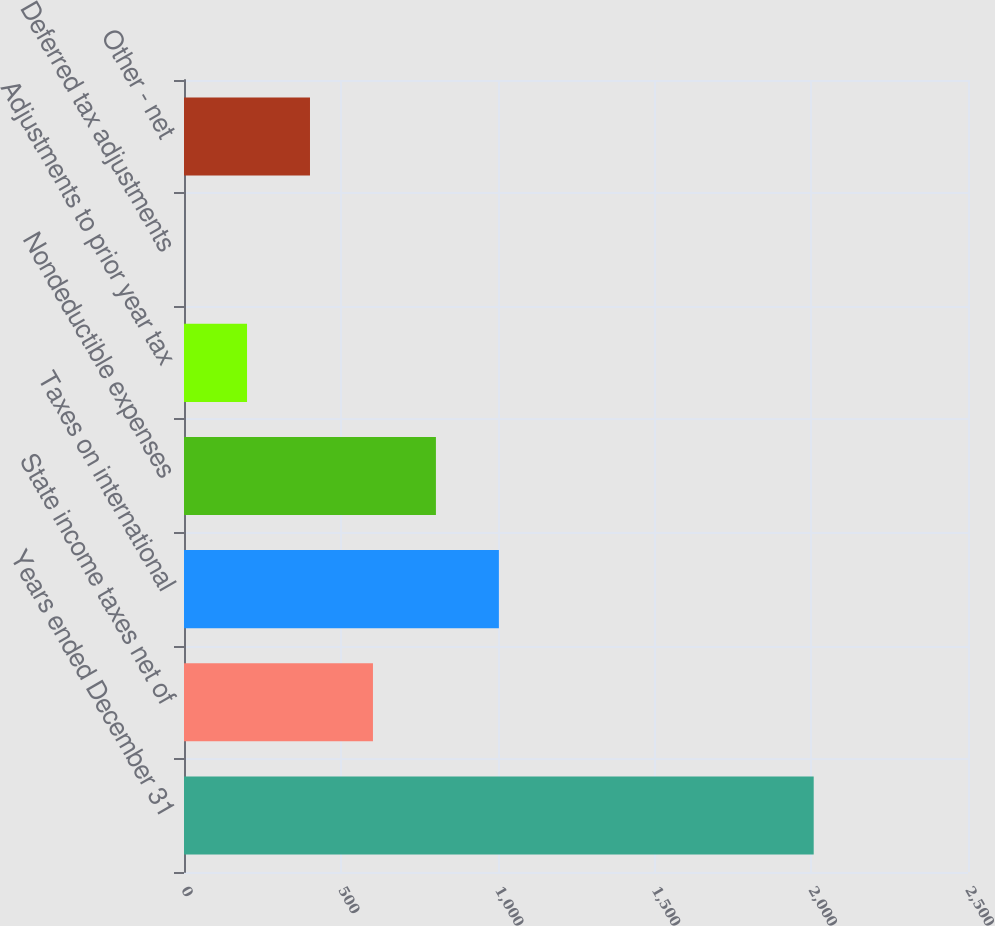Convert chart to OTSL. <chart><loc_0><loc_0><loc_500><loc_500><bar_chart><fcel>Years ended December 31<fcel>State income taxes net of<fcel>Taxes on international<fcel>Nondeductible expenses<fcel>Adjustments to prior year tax<fcel>Deferred tax adjustments<fcel>Other - net<nl><fcel>2008<fcel>602.54<fcel>1004.1<fcel>803.32<fcel>200.98<fcel>0.2<fcel>401.76<nl></chart> 